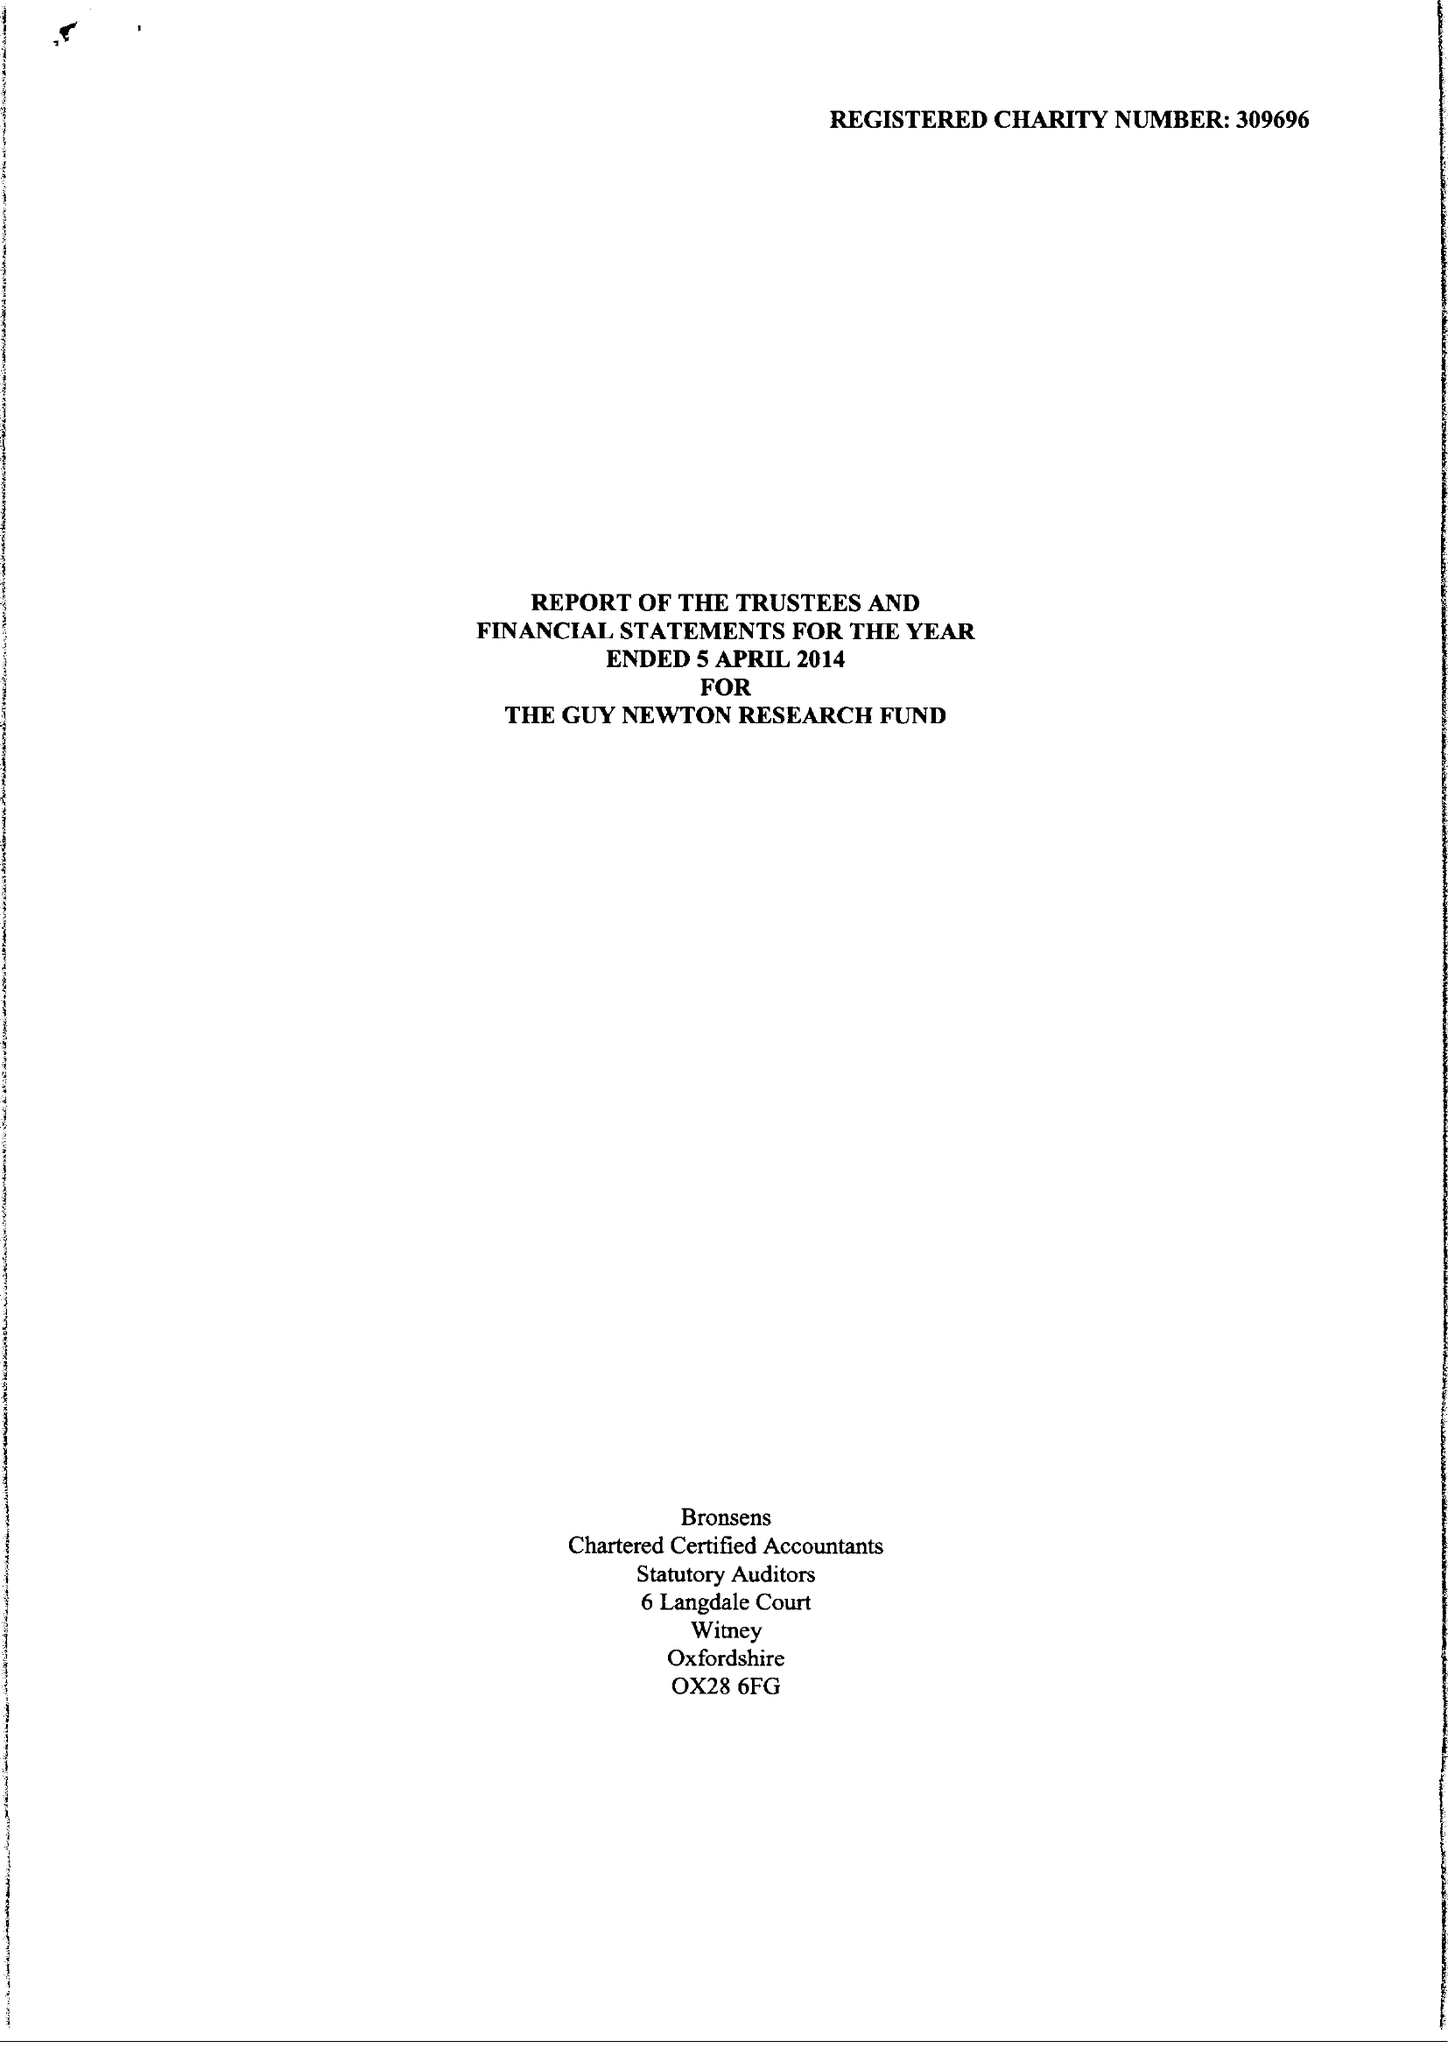What is the value for the address__post_town?
Answer the question using a single word or phrase. OXFORD 